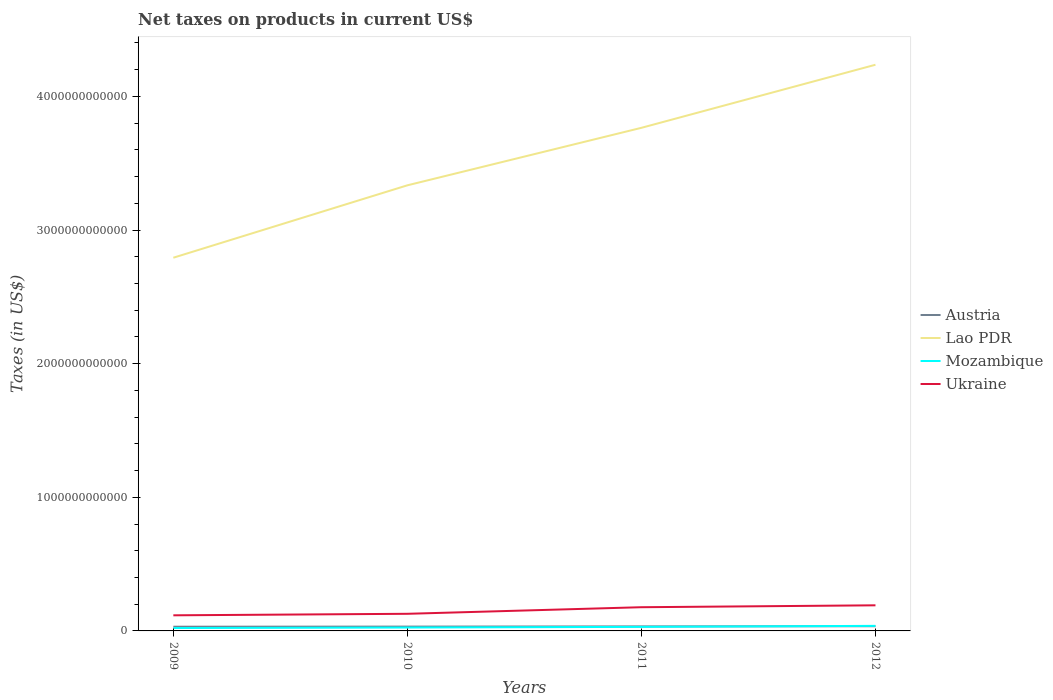How many different coloured lines are there?
Offer a terse response. 4. Across all years, what is the maximum net taxes on products in Ukraine?
Your answer should be compact. 1.17e+11. What is the total net taxes on products in Austria in the graph?
Keep it short and to the point. -3.74e+09. What is the difference between the highest and the second highest net taxes on products in Austria?
Provide a succinct answer. 3.74e+09. Is the net taxes on products in Ukraine strictly greater than the net taxes on products in Lao PDR over the years?
Provide a succinct answer. Yes. How many lines are there?
Provide a succinct answer. 4. What is the difference between two consecutive major ticks on the Y-axis?
Your answer should be very brief. 1.00e+12. Are the values on the major ticks of Y-axis written in scientific E-notation?
Make the answer very short. No. Does the graph contain grids?
Provide a short and direct response. No. What is the title of the graph?
Offer a terse response. Net taxes on products in current US$. Does "Bhutan" appear as one of the legend labels in the graph?
Make the answer very short. No. What is the label or title of the Y-axis?
Offer a terse response. Taxes (in US$). What is the Taxes (in US$) in Austria in 2009?
Provide a succinct answer. 3.14e+1. What is the Taxes (in US$) in Lao PDR in 2009?
Offer a terse response. 2.79e+12. What is the Taxes (in US$) of Mozambique in 2009?
Keep it short and to the point. 2.17e+1. What is the Taxes (in US$) in Ukraine in 2009?
Offer a very short reply. 1.17e+11. What is the Taxes (in US$) in Austria in 2010?
Offer a very short reply. 3.23e+1. What is the Taxes (in US$) in Lao PDR in 2010?
Ensure brevity in your answer.  3.33e+12. What is the Taxes (in US$) in Mozambique in 2010?
Offer a terse response. 2.55e+1. What is the Taxes (in US$) in Ukraine in 2010?
Your response must be concise. 1.28e+11. What is the Taxes (in US$) in Austria in 2011?
Give a very brief answer. 3.38e+1. What is the Taxes (in US$) in Lao PDR in 2011?
Your response must be concise. 3.76e+12. What is the Taxes (in US$) in Mozambique in 2011?
Offer a very short reply. 3.03e+1. What is the Taxes (in US$) of Ukraine in 2011?
Provide a succinct answer. 1.77e+11. What is the Taxes (in US$) of Austria in 2012?
Provide a short and direct response. 3.52e+1. What is the Taxes (in US$) of Lao PDR in 2012?
Ensure brevity in your answer.  4.24e+12. What is the Taxes (in US$) in Mozambique in 2012?
Keep it short and to the point. 3.79e+1. What is the Taxes (in US$) in Ukraine in 2012?
Keep it short and to the point. 1.92e+11. Across all years, what is the maximum Taxes (in US$) in Austria?
Ensure brevity in your answer.  3.52e+1. Across all years, what is the maximum Taxes (in US$) in Lao PDR?
Your answer should be very brief. 4.24e+12. Across all years, what is the maximum Taxes (in US$) of Mozambique?
Your response must be concise. 3.79e+1. Across all years, what is the maximum Taxes (in US$) in Ukraine?
Your response must be concise. 1.92e+11. Across all years, what is the minimum Taxes (in US$) in Austria?
Your response must be concise. 3.14e+1. Across all years, what is the minimum Taxes (in US$) of Lao PDR?
Ensure brevity in your answer.  2.79e+12. Across all years, what is the minimum Taxes (in US$) of Mozambique?
Your response must be concise. 2.17e+1. Across all years, what is the minimum Taxes (in US$) of Ukraine?
Offer a terse response. 1.17e+11. What is the total Taxes (in US$) in Austria in the graph?
Make the answer very short. 1.33e+11. What is the total Taxes (in US$) in Lao PDR in the graph?
Give a very brief answer. 1.41e+13. What is the total Taxes (in US$) in Mozambique in the graph?
Keep it short and to the point. 1.15e+11. What is the total Taxes (in US$) of Ukraine in the graph?
Provide a succinct answer. 6.14e+11. What is the difference between the Taxes (in US$) of Austria in 2009 and that in 2010?
Your answer should be very brief. -8.90e+08. What is the difference between the Taxes (in US$) in Lao PDR in 2009 and that in 2010?
Your response must be concise. -5.42e+11. What is the difference between the Taxes (in US$) of Mozambique in 2009 and that in 2010?
Give a very brief answer. -3.78e+09. What is the difference between the Taxes (in US$) in Ukraine in 2009 and that in 2010?
Your answer should be very brief. -1.12e+1. What is the difference between the Taxes (in US$) in Austria in 2009 and that in 2011?
Make the answer very short. -2.35e+09. What is the difference between the Taxes (in US$) of Lao PDR in 2009 and that in 2011?
Your answer should be compact. -9.72e+11. What is the difference between the Taxes (in US$) in Mozambique in 2009 and that in 2011?
Keep it short and to the point. -8.59e+09. What is the difference between the Taxes (in US$) in Ukraine in 2009 and that in 2011?
Make the answer very short. -6.06e+1. What is the difference between the Taxes (in US$) in Austria in 2009 and that in 2012?
Keep it short and to the point. -3.74e+09. What is the difference between the Taxes (in US$) of Lao PDR in 2009 and that in 2012?
Your answer should be very brief. -1.44e+12. What is the difference between the Taxes (in US$) of Mozambique in 2009 and that in 2012?
Make the answer very short. -1.62e+1. What is the difference between the Taxes (in US$) in Ukraine in 2009 and that in 2012?
Offer a very short reply. -7.47e+1. What is the difference between the Taxes (in US$) of Austria in 2010 and that in 2011?
Your answer should be compact. -1.46e+09. What is the difference between the Taxes (in US$) of Lao PDR in 2010 and that in 2011?
Offer a very short reply. -4.30e+11. What is the difference between the Taxes (in US$) of Mozambique in 2010 and that in 2011?
Give a very brief answer. -4.81e+09. What is the difference between the Taxes (in US$) in Ukraine in 2010 and that in 2011?
Provide a succinct answer. -4.93e+1. What is the difference between the Taxes (in US$) of Austria in 2010 and that in 2012?
Provide a short and direct response. -2.85e+09. What is the difference between the Taxes (in US$) in Lao PDR in 2010 and that in 2012?
Offer a terse response. -9.02e+11. What is the difference between the Taxes (in US$) of Mozambique in 2010 and that in 2012?
Ensure brevity in your answer.  -1.24e+1. What is the difference between the Taxes (in US$) in Ukraine in 2010 and that in 2012?
Offer a very short reply. -6.35e+1. What is the difference between the Taxes (in US$) of Austria in 2011 and that in 2012?
Ensure brevity in your answer.  -1.38e+09. What is the difference between the Taxes (in US$) in Lao PDR in 2011 and that in 2012?
Keep it short and to the point. -4.72e+11. What is the difference between the Taxes (in US$) of Mozambique in 2011 and that in 2012?
Provide a succinct answer. -7.59e+09. What is the difference between the Taxes (in US$) in Ukraine in 2011 and that in 2012?
Offer a terse response. -1.42e+1. What is the difference between the Taxes (in US$) of Austria in 2009 and the Taxes (in US$) of Lao PDR in 2010?
Ensure brevity in your answer.  -3.30e+12. What is the difference between the Taxes (in US$) in Austria in 2009 and the Taxes (in US$) in Mozambique in 2010?
Ensure brevity in your answer.  5.97e+09. What is the difference between the Taxes (in US$) in Austria in 2009 and the Taxes (in US$) in Ukraine in 2010?
Your answer should be compact. -9.67e+1. What is the difference between the Taxes (in US$) in Lao PDR in 2009 and the Taxes (in US$) in Mozambique in 2010?
Give a very brief answer. 2.77e+12. What is the difference between the Taxes (in US$) of Lao PDR in 2009 and the Taxes (in US$) of Ukraine in 2010?
Your response must be concise. 2.66e+12. What is the difference between the Taxes (in US$) of Mozambique in 2009 and the Taxes (in US$) of Ukraine in 2010?
Give a very brief answer. -1.06e+11. What is the difference between the Taxes (in US$) in Austria in 2009 and the Taxes (in US$) in Lao PDR in 2011?
Your answer should be very brief. -3.73e+12. What is the difference between the Taxes (in US$) of Austria in 2009 and the Taxes (in US$) of Mozambique in 2011?
Offer a very short reply. 1.16e+09. What is the difference between the Taxes (in US$) in Austria in 2009 and the Taxes (in US$) in Ukraine in 2011?
Offer a terse response. -1.46e+11. What is the difference between the Taxes (in US$) in Lao PDR in 2009 and the Taxes (in US$) in Mozambique in 2011?
Provide a short and direct response. 2.76e+12. What is the difference between the Taxes (in US$) of Lao PDR in 2009 and the Taxes (in US$) of Ukraine in 2011?
Your answer should be compact. 2.62e+12. What is the difference between the Taxes (in US$) in Mozambique in 2009 and the Taxes (in US$) in Ukraine in 2011?
Give a very brief answer. -1.56e+11. What is the difference between the Taxes (in US$) of Austria in 2009 and the Taxes (in US$) of Lao PDR in 2012?
Offer a very short reply. -4.21e+12. What is the difference between the Taxes (in US$) in Austria in 2009 and the Taxes (in US$) in Mozambique in 2012?
Your answer should be compact. -6.43e+09. What is the difference between the Taxes (in US$) in Austria in 2009 and the Taxes (in US$) in Ukraine in 2012?
Make the answer very short. -1.60e+11. What is the difference between the Taxes (in US$) of Lao PDR in 2009 and the Taxes (in US$) of Mozambique in 2012?
Keep it short and to the point. 2.75e+12. What is the difference between the Taxes (in US$) in Lao PDR in 2009 and the Taxes (in US$) in Ukraine in 2012?
Ensure brevity in your answer.  2.60e+12. What is the difference between the Taxes (in US$) of Mozambique in 2009 and the Taxes (in US$) of Ukraine in 2012?
Give a very brief answer. -1.70e+11. What is the difference between the Taxes (in US$) of Austria in 2010 and the Taxes (in US$) of Lao PDR in 2011?
Offer a terse response. -3.73e+12. What is the difference between the Taxes (in US$) in Austria in 2010 and the Taxes (in US$) in Mozambique in 2011?
Your answer should be compact. 2.05e+09. What is the difference between the Taxes (in US$) in Austria in 2010 and the Taxes (in US$) in Ukraine in 2011?
Give a very brief answer. -1.45e+11. What is the difference between the Taxes (in US$) of Lao PDR in 2010 and the Taxes (in US$) of Mozambique in 2011?
Offer a very short reply. 3.30e+12. What is the difference between the Taxes (in US$) in Lao PDR in 2010 and the Taxes (in US$) in Ukraine in 2011?
Ensure brevity in your answer.  3.16e+12. What is the difference between the Taxes (in US$) in Mozambique in 2010 and the Taxes (in US$) in Ukraine in 2011?
Your response must be concise. -1.52e+11. What is the difference between the Taxes (in US$) in Austria in 2010 and the Taxes (in US$) in Lao PDR in 2012?
Ensure brevity in your answer.  -4.20e+12. What is the difference between the Taxes (in US$) of Austria in 2010 and the Taxes (in US$) of Mozambique in 2012?
Provide a short and direct response. -5.54e+09. What is the difference between the Taxes (in US$) of Austria in 2010 and the Taxes (in US$) of Ukraine in 2012?
Make the answer very short. -1.59e+11. What is the difference between the Taxes (in US$) in Lao PDR in 2010 and the Taxes (in US$) in Mozambique in 2012?
Ensure brevity in your answer.  3.30e+12. What is the difference between the Taxes (in US$) in Lao PDR in 2010 and the Taxes (in US$) in Ukraine in 2012?
Provide a short and direct response. 3.14e+12. What is the difference between the Taxes (in US$) of Mozambique in 2010 and the Taxes (in US$) of Ukraine in 2012?
Your response must be concise. -1.66e+11. What is the difference between the Taxes (in US$) in Austria in 2011 and the Taxes (in US$) in Lao PDR in 2012?
Provide a succinct answer. -4.20e+12. What is the difference between the Taxes (in US$) of Austria in 2011 and the Taxes (in US$) of Mozambique in 2012?
Your response must be concise. -4.07e+09. What is the difference between the Taxes (in US$) of Austria in 2011 and the Taxes (in US$) of Ukraine in 2012?
Make the answer very short. -1.58e+11. What is the difference between the Taxes (in US$) of Lao PDR in 2011 and the Taxes (in US$) of Mozambique in 2012?
Keep it short and to the point. 3.73e+12. What is the difference between the Taxes (in US$) in Lao PDR in 2011 and the Taxes (in US$) in Ukraine in 2012?
Offer a very short reply. 3.57e+12. What is the difference between the Taxes (in US$) of Mozambique in 2011 and the Taxes (in US$) of Ukraine in 2012?
Offer a very short reply. -1.61e+11. What is the average Taxes (in US$) of Austria per year?
Your response must be concise. 3.32e+1. What is the average Taxes (in US$) in Lao PDR per year?
Your answer should be compact. 3.53e+12. What is the average Taxes (in US$) of Mozambique per year?
Provide a succinct answer. 2.88e+1. What is the average Taxes (in US$) in Ukraine per year?
Give a very brief answer. 1.54e+11. In the year 2009, what is the difference between the Taxes (in US$) of Austria and Taxes (in US$) of Lao PDR?
Make the answer very short. -2.76e+12. In the year 2009, what is the difference between the Taxes (in US$) of Austria and Taxes (in US$) of Mozambique?
Your response must be concise. 9.75e+09. In the year 2009, what is the difference between the Taxes (in US$) in Austria and Taxes (in US$) in Ukraine?
Offer a very short reply. -8.54e+1. In the year 2009, what is the difference between the Taxes (in US$) of Lao PDR and Taxes (in US$) of Mozambique?
Provide a short and direct response. 2.77e+12. In the year 2009, what is the difference between the Taxes (in US$) of Lao PDR and Taxes (in US$) of Ukraine?
Offer a very short reply. 2.68e+12. In the year 2009, what is the difference between the Taxes (in US$) in Mozambique and Taxes (in US$) in Ukraine?
Your answer should be compact. -9.52e+1. In the year 2010, what is the difference between the Taxes (in US$) in Austria and Taxes (in US$) in Lao PDR?
Your answer should be compact. -3.30e+12. In the year 2010, what is the difference between the Taxes (in US$) in Austria and Taxes (in US$) in Mozambique?
Keep it short and to the point. 6.86e+09. In the year 2010, what is the difference between the Taxes (in US$) in Austria and Taxes (in US$) in Ukraine?
Your response must be concise. -9.58e+1. In the year 2010, what is the difference between the Taxes (in US$) of Lao PDR and Taxes (in US$) of Mozambique?
Your answer should be very brief. 3.31e+12. In the year 2010, what is the difference between the Taxes (in US$) in Lao PDR and Taxes (in US$) in Ukraine?
Give a very brief answer. 3.21e+12. In the year 2010, what is the difference between the Taxes (in US$) of Mozambique and Taxes (in US$) of Ukraine?
Ensure brevity in your answer.  -1.03e+11. In the year 2011, what is the difference between the Taxes (in US$) of Austria and Taxes (in US$) of Lao PDR?
Make the answer very short. -3.73e+12. In the year 2011, what is the difference between the Taxes (in US$) of Austria and Taxes (in US$) of Mozambique?
Offer a terse response. 3.52e+09. In the year 2011, what is the difference between the Taxes (in US$) of Austria and Taxes (in US$) of Ukraine?
Make the answer very short. -1.44e+11. In the year 2011, what is the difference between the Taxes (in US$) in Lao PDR and Taxes (in US$) in Mozambique?
Your answer should be compact. 3.73e+12. In the year 2011, what is the difference between the Taxes (in US$) of Lao PDR and Taxes (in US$) of Ukraine?
Provide a succinct answer. 3.59e+12. In the year 2011, what is the difference between the Taxes (in US$) in Mozambique and Taxes (in US$) in Ukraine?
Make the answer very short. -1.47e+11. In the year 2012, what is the difference between the Taxes (in US$) in Austria and Taxes (in US$) in Lao PDR?
Ensure brevity in your answer.  -4.20e+12. In the year 2012, what is the difference between the Taxes (in US$) in Austria and Taxes (in US$) in Mozambique?
Provide a succinct answer. -2.69e+09. In the year 2012, what is the difference between the Taxes (in US$) in Austria and Taxes (in US$) in Ukraine?
Provide a short and direct response. -1.56e+11. In the year 2012, what is the difference between the Taxes (in US$) in Lao PDR and Taxes (in US$) in Mozambique?
Keep it short and to the point. 4.20e+12. In the year 2012, what is the difference between the Taxes (in US$) in Lao PDR and Taxes (in US$) in Ukraine?
Ensure brevity in your answer.  4.05e+12. In the year 2012, what is the difference between the Taxes (in US$) in Mozambique and Taxes (in US$) in Ukraine?
Provide a short and direct response. -1.54e+11. What is the ratio of the Taxes (in US$) of Austria in 2009 to that in 2010?
Make the answer very short. 0.97. What is the ratio of the Taxes (in US$) of Lao PDR in 2009 to that in 2010?
Offer a very short reply. 0.84. What is the ratio of the Taxes (in US$) in Mozambique in 2009 to that in 2010?
Your response must be concise. 0.85. What is the ratio of the Taxes (in US$) in Ukraine in 2009 to that in 2010?
Make the answer very short. 0.91. What is the ratio of the Taxes (in US$) in Austria in 2009 to that in 2011?
Give a very brief answer. 0.93. What is the ratio of the Taxes (in US$) of Lao PDR in 2009 to that in 2011?
Your response must be concise. 0.74. What is the ratio of the Taxes (in US$) in Mozambique in 2009 to that in 2011?
Your answer should be very brief. 0.72. What is the ratio of the Taxes (in US$) in Ukraine in 2009 to that in 2011?
Provide a succinct answer. 0.66. What is the ratio of the Taxes (in US$) of Austria in 2009 to that in 2012?
Ensure brevity in your answer.  0.89. What is the ratio of the Taxes (in US$) in Lao PDR in 2009 to that in 2012?
Provide a succinct answer. 0.66. What is the ratio of the Taxes (in US$) of Mozambique in 2009 to that in 2012?
Provide a succinct answer. 0.57. What is the ratio of the Taxes (in US$) in Ukraine in 2009 to that in 2012?
Your response must be concise. 0.61. What is the ratio of the Taxes (in US$) in Austria in 2010 to that in 2011?
Provide a short and direct response. 0.96. What is the ratio of the Taxes (in US$) in Lao PDR in 2010 to that in 2011?
Offer a terse response. 0.89. What is the ratio of the Taxes (in US$) of Mozambique in 2010 to that in 2011?
Give a very brief answer. 0.84. What is the ratio of the Taxes (in US$) in Ukraine in 2010 to that in 2011?
Ensure brevity in your answer.  0.72. What is the ratio of the Taxes (in US$) in Austria in 2010 to that in 2012?
Offer a very short reply. 0.92. What is the ratio of the Taxes (in US$) of Lao PDR in 2010 to that in 2012?
Make the answer very short. 0.79. What is the ratio of the Taxes (in US$) in Mozambique in 2010 to that in 2012?
Make the answer very short. 0.67. What is the ratio of the Taxes (in US$) of Ukraine in 2010 to that in 2012?
Provide a short and direct response. 0.67. What is the ratio of the Taxes (in US$) of Austria in 2011 to that in 2012?
Provide a succinct answer. 0.96. What is the ratio of the Taxes (in US$) in Lao PDR in 2011 to that in 2012?
Give a very brief answer. 0.89. What is the ratio of the Taxes (in US$) in Mozambique in 2011 to that in 2012?
Offer a very short reply. 0.8. What is the ratio of the Taxes (in US$) in Ukraine in 2011 to that in 2012?
Give a very brief answer. 0.93. What is the difference between the highest and the second highest Taxes (in US$) of Austria?
Provide a succinct answer. 1.38e+09. What is the difference between the highest and the second highest Taxes (in US$) in Lao PDR?
Offer a very short reply. 4.72e+11. What is the difference between the highest and the second highest Taxes (in US$) in Mozambique?
Keep it short and to the point. 7.59e+09. What is the difference between the highest and the second highest Taxes (in US$) in Ukraine?
Provide a succinct answer. 1.42e+1. What is the difference between the highest and the lowest Taxes (in US$) in Austria?
Your response must be concise. 3.74e+09. What is the difference between the highest and the lowest Taxes (in US$) in Lao PDR?
Offer a very short reply. 1.44e+12. What is the difference between the highest and the lowest Taxes (in US$) of Mozambique?
Ensure brevity in your answer.  1.62e+1. What is the difference between the highest and the lowest Taxes (in US$) in Ukraine?
Your answer should be compact. 7.47e+1. 